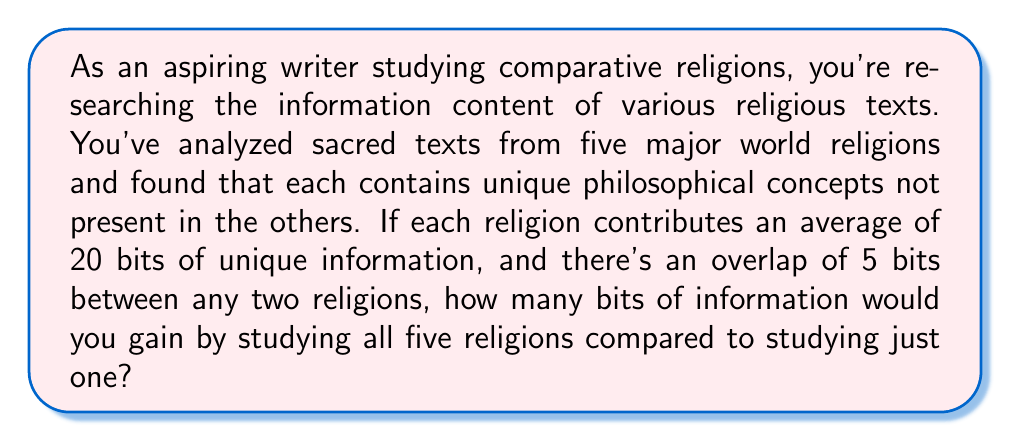Show me your answer to this math problem. Let's approach this step-by-step using concepts from information theory:

1) First, let's consider the information content of a single religion:
   Each religion contributes 20 bits of unique information.

2) Now, let's consider what happens when we add a second religion:
   - It adds 20 bits of its own unique information
   - But 5 bits overlap with the first religion
   So, the second religion contributes an additional 15 bits (20 - 5)

3) For the third religion:
   - It adds 20 bits of its own unique information
   - But it overlaps 5 bits with each of the two previous religions
   So, the third religion contributes an additional 10 bits (20 - 5 - 5)

4) Following this pattern, the fourth religion will contribute 5 bits, and the fifth will contribute 0 bits.

5) Let's sum up the total information gain:
   $$\text{Total Information} = 20 + 15 + 10 + 5 + 0 = 50\text{ bits}$$

6) The question asks for the gain compared to studying just one religion:
   $$\text{Information Gain} = 50 - 20 = 30\text{ bits}$$

This result makes intuitive sense: each additional religion adds less new information due to increasing overlap, but there's still a substantial gain from studying multiple perspectives.
Answer: 30 bits 